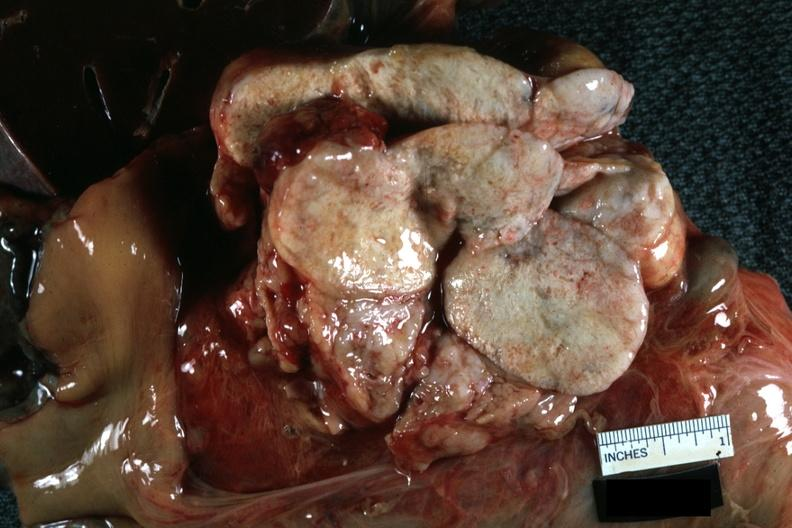what is present?
Answer the question using a single word or phrase. Lymph node 